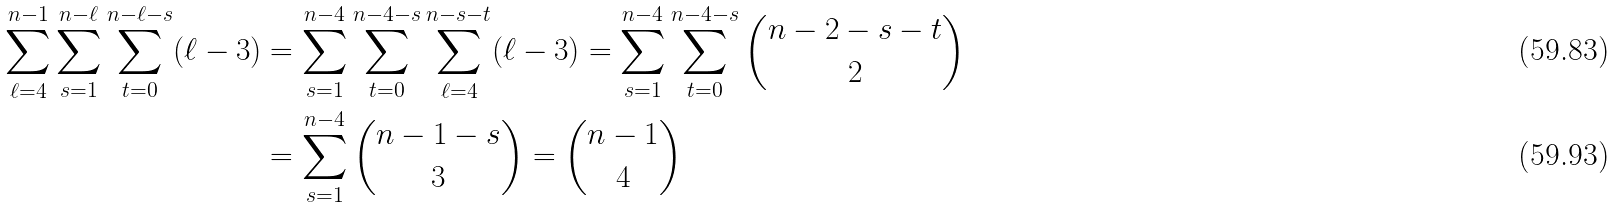Convert formula to latex. <formula><loc_0><loc_0><loc_500><loc_500>\sum _ { \ell = 4 } ^ { n - 1 } \sum _ { s = 1 } ^ { n - \ell } \sum _ { t = 0 } ^ { n - \ell - s } ( \ell - 3 ) & = \sum _ { s = 1 } ^ { n - 4 } \sum _ { t = 0 } ^ { n - 4 - s } \sum _ { \ell = 4 } ^ { n - s - t } ( \ell - 3 ) = \sum _ { s = 1 } ^ { n - 4 } \sum _ { t = 0 } ^ { n - 4 - s } \binom { n - 2 - s - t } { 2 } \\ & = \sum _ { s = 1 } ^ { n - 4 } \binom { n - 1 - s } { 3 } = \binom { n - 1 } { 4 }</formula> 